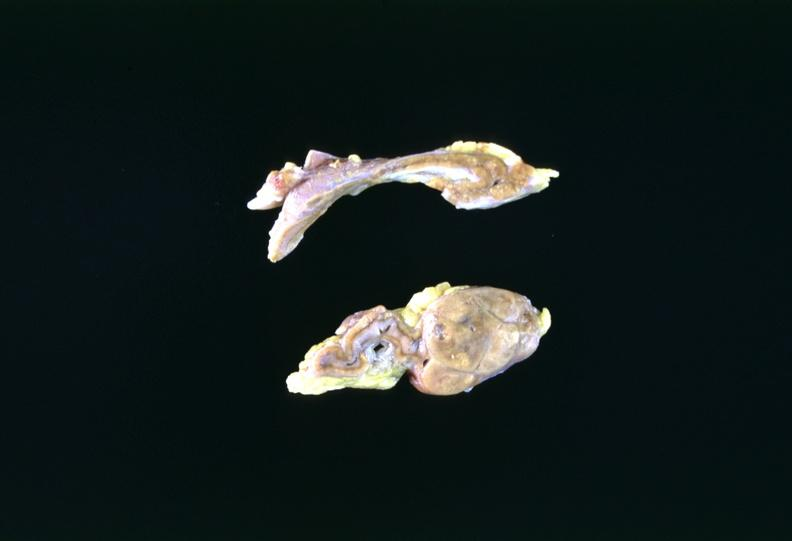does this image show adrenal tumor?
Answer the question using a single word or phrase. Yes 